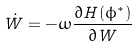<formula> <loc_0><loc_0><loc_500><loc_500>\dot { W } = - \omega \frac { \partial H ( \phi ^ { * } ) } { \partial W }</formula> 